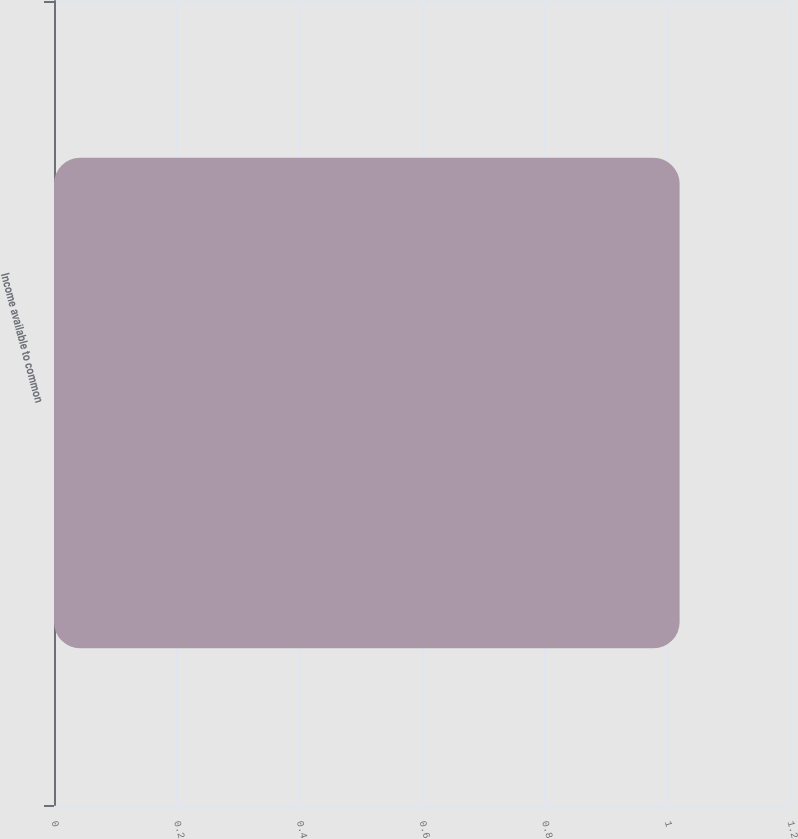Convert chart to OTSL. <chart><loc_0><loc_0><loc_500><loc_500><bar_chart><fcel>Income available to common<nl><fcel>1.02<nl></chart> 